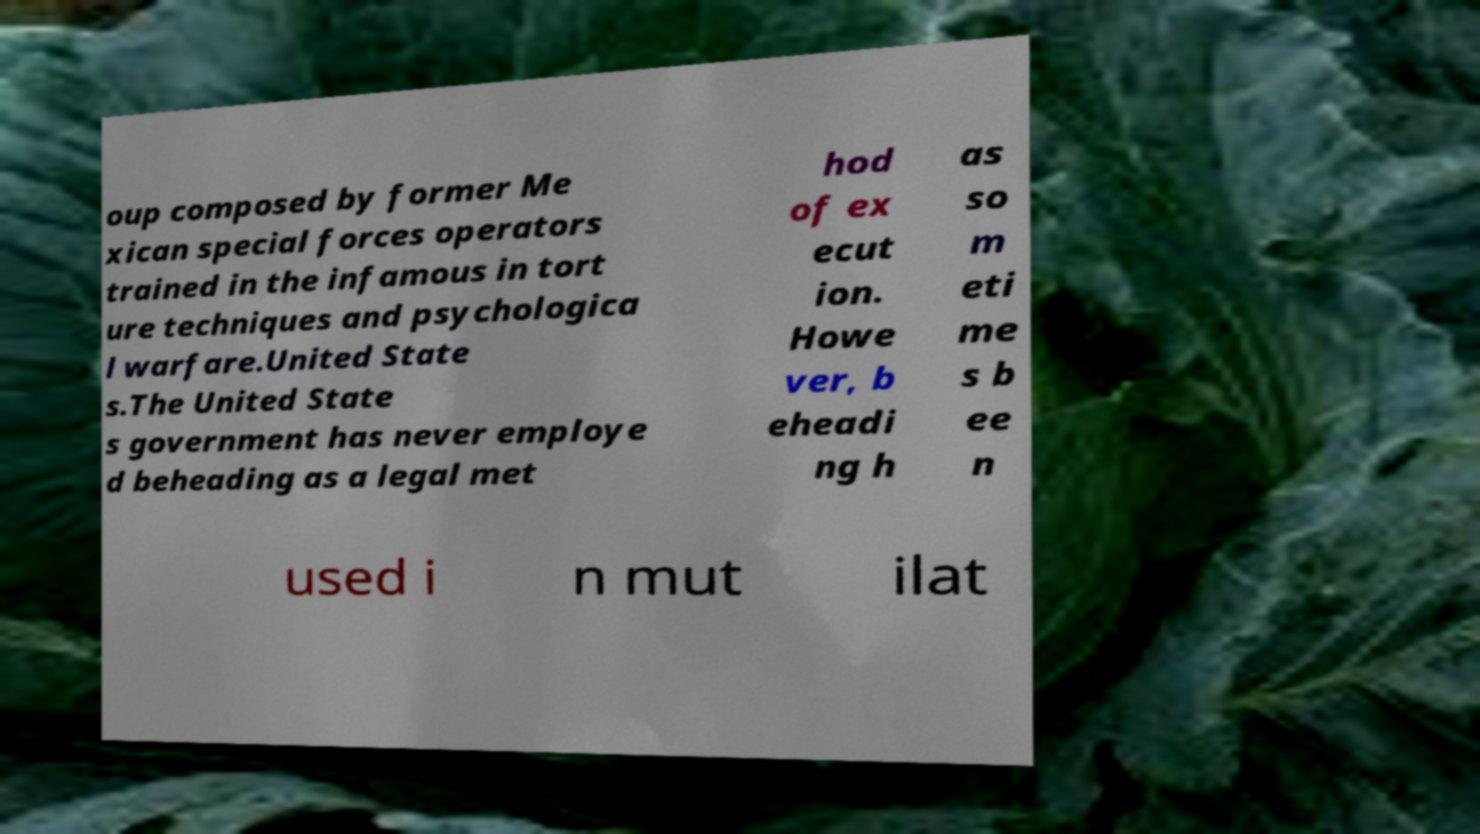Could you assist in decoding the text presented in this image and type it out clearly? oup composed by former Me xican special forces operators trained in the infamous in tort ure techniques and psychologica l warfare.United State s.The United State s government has never employe d beheading as a legal met hod of ex ecut ion. Howe ver, b eheadi ng h as so m eti me s b ee n used i n mut ilat 